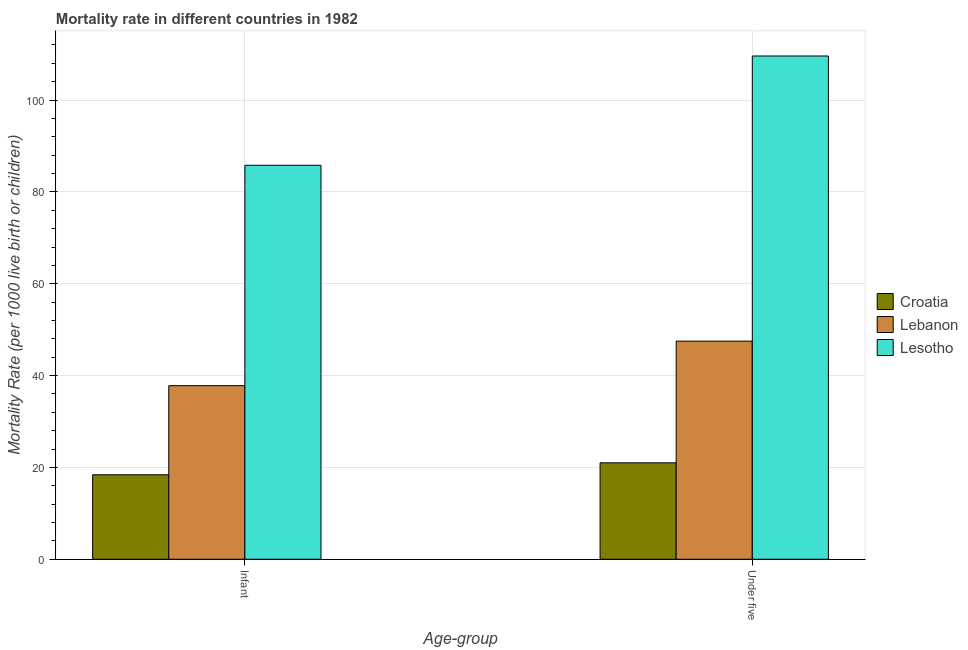How many different coloured bars are there?
Provide a short and direct response. 3. How many groups of bars are there?
Your answer should be very brief. 2. Are the number of bars per tick equal to the number of legend labels?
Provide a short and direct response. Yes. Are the number of bars on each tick of the X-axis equal?
Give a very brief answer. Yes. How many bars are there on the 1st tick from the left?
Offer a terse response. 3. What is the label of the 1st group of bars from the left?
Provide a succinct answer. Infant. What is the infant mortality rate in Lebanon?
Keep it short and to the point. 37.8. Across all countries, what is the maximum under-5 mortality rate?
Your response must be concise. 109.6. Across all countries, what is the minimum infant mortality rate?
Give a very brief answer. 18.4. In which country was the infant mortality rate maximum?
Your answer should be compact. Lesotho. In which country was the infant mortality rate minimum?
Your answer should be compact. Croatia. What is the total under-5 mortality rate in the graph?
Ensure brevity in your answer.  178.1. What is the difference between the infant mortality rate in Lesotho and that in Lebanon?
Give a very brief answer. 48. What is the difference between the under-5 mortality rate in Lebanon and the infant mortality rate in Lesotho?
Give a very brief answer. -38.3. What is the average infant mortality rate per country?
Ensure brevity in your answer.  47.33. What is the difference between the under-5 mortality rate and infant mortality rate in Lebanon?
Your response must be concise. 9.7. In how many countries, is the under-5 mortality rate greater than 68 ?
Keep it short and to the point. 1. What is the ratio of the under-5 mortality rate in Lesotho to that in Croatia?
Provide a succinct answer. 5.22. In how many countries, is the under-5 mortality rate greater than the average under-5 mortality rate taken over all countries?
Your answer should be very brief. 1. What does the 1st bar from the left in Infant represents?
Offer a terse response. Croatia. What does the 1st bar from the right in Under five represents?
Offer a very short reply. Lesotho. How many bars are there?
Provide a succinct answer. 6. Where does the legend appear in the graph?
Make the answer very short. Center right. What is the title of the graph?
Your answer should be very brief. Mortality rate in different countries in 1982. Does "Cameroon" appear as one of the legend labels in the graph?
Offer a terse response. No. What is the label or title of the X-axis?
Your response must be concise. Age-group. What is the label or title of the Y-axis?
Offer a terse response. Mortality Rate (per 1000 live birth or children). What is the Mortality Rate (per 1000 live birth or children) of Lebanon in Infant?
Give a very brief answer. 37.8. What is the Mortality Rate (per 1000 live birth or children) in Lesotho in Infant?
Make the answer very short. 85.8. What is the Mortality Rate (per 1000 live birth or children) of Lebanon in Under five?
Provide a short and direct response. 47.5. What is the Mortality Rate (per 1000 live birth or children) of Lesotho in Under five?
Provide a short and direct response. 109.6. Across all Age-group, what is the maximum Mortality Rate (per 1000 live birth or children) in Croatia?
Make the answer very short. 21. Across all Age-group, what is the maximum Mortality Rate (per 1000 live birth or children) of Lebanon?
Your answer should be very brief. 47.5. Across all Age-group, what is the maximum Mortality Rate (per 1000 live birth or children) of Lesotho?
Provide a succinct answer. 109.6. Across all Age-group, what is the minimum Mortality Rate (per 1000 live birth or children) in Croatia?
Your answer should be compact. 18.4. Across all Age-group, what is the minimum Mortality Rate (per 1000 live birth or children) in Lebanon?
Offer a very short reply. 37.8. Across all Age-group, what is the minimum Mortality Rate (per 1000 live birth or children) of Lesotho?
Offer a very short reply. 85.8. What is the total Mortality Rate (per 1000 live birth or children) in Croatia in the graph?
Provide a succinct answer. 39.4. What is the total Mortality Rate (per 1000 live birth or children) of Lebanon in the graph?
Make the answer very short. 85.3. What is the total Mortality Rate (per 1000 live birth or children) in Lesotho in the graph?
Ensure brevity in your answer.  195.4. What is the difference between the Mortality Rate (per 1000 live birth or children) of Lebanon in Infant and that in Under five?
Offer a terse response. -9.7. What is the difference between the Mortality Rate (per 1000 live birth or children) of Lesotho in Infant and that in Under five?
Offer a very short reply. -23.8. What is the difference between the Mortality Rate (per 1000 live birth or children) of Croatia in Infant and the Mortality Rate (per 1000 live birth or children) of Lebanon in Under five?
Your answer should be very brief. -29.1. What is the difference between the Mortality Rate (per 1000 live birth or children) in Croatia in Infant and the Mortality Rate (per 1000 live birth or children) in Lesotho in Under five?
Ensure brevity in your answer.  -91.2. What is the difference between the Mortality Rate (per 1000 live birth or children) in Lebanon in Infant and the Mortality Rate (per 1000 live birth or children) in Lesotho in Under five?
Your response must be concise. -71.8. What is the average Mortality Rate (per 1000 live birth or children) of Lebanon per Age-group?
Give a very brief answer. 42.65. What is the average Mortality Rate (per 1000 live birth or children) in Lesotho per Age-group?
Your answer should be very brief. 97.7. What is the difference between the Mortality Rate (per 1000 live birth or children) of Croatia and Mortality Rate (per 1000 live birth or children) of Lebanon in Infant?
Offer a terse response. -19.4. What is the difference between the Mortality Rate (per 1000 live birth or children) in Croatia and Mortality Rate (per 1000 live birth or children) in Lesotho in Infant?
Give a very brief answer. -67.4. What is the difference between the Mortality Rate (per 1000 live birth or children) of Lebanon and Mortality Rate (per 1000 live birth or children) of Lesotho in Infant?
Provide a short and direct response. -48. What is the difference between the Mortality Rate (per 1000 live birth or children) in Croatia and Mortality Rate (per 1000 live birth or children) in Lebanon in Under five?
Make the answer very short. -26.5. What is the difference between the Mortality Rate (per 1000 live birth or children) in Croatia and Mortality Rate (per 1000 live birth or children) in Lesotho in Under five?
Ensure brevity in your answer.  -88.6. What is the difference between the Mortality Rate (per 1000 live birth or children) in Lebanon and Mortality Rate (per 1000 live birth or children) in Lesotho in Under five?
Ensure brevity in your answer.  -62.1. What is the ratio of the Mortality Rate (per 1000 live birth or children) of Croatia in Infant to that in Under five?
Your response must be concise. 0.88. What is the ratio of the Mortality Rate (per 1000 live birth or children) in Lebanon in Infant to that in Under five?
Provide a succinct answer. 0.8. What is the ratio of the Mortality Rate (per 1000 live birth or children) of Lesotho in Infant to that in Under five?
Provide a succinct answer. 0.78. What is the difference between the highest and the second highest Mortality Rate (per 1000 live birth or children) of Croatia?
Give a very brief answer. 2.6. What is the difference between the highest and the second highest Mortality Rate (per 1000 live birth or children) of Lebanon?
Your answer should be compact. 9.7. What is the difference between the highest and the second highest Mortality Rate (per 1000 live birth or children) of Lesotho?
Provide a succinct answer. 23.8. What is the difference between the highest and the lowest Mortality Rate (per 1000 live birth or children) in Lesotho?
Keep it short and to the point. 23.8. 